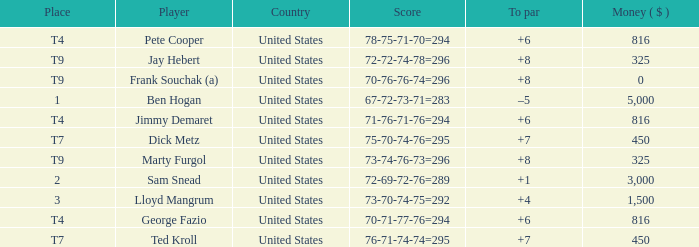Which country is Pete Cooper, who made $816, from? United States. Parse the full table. {'header': ['Place', 'Player', 'Country', 'Score', 'To par', 'Money ( $ )'], 'rows': [['T4', 'Pete Cooper', 'United States', '78-75-71-70=294', '+6', '816'], ['T9', 'Jay Hebert', 'United States', '72-72-74-78=296', '+8', '325'], ['T9', 'Frank Souchak (a)', 'United States', '70-76-76-74=296', '+8', '0'], ['1', 'Ben Hogan', 'United States', '67-72-73-71=283', '–5', '5,000'], ['T4', 'Jimmy Demaret', 'United States', '71-76-71-76=294', '+6', '816'], ['T7', 'Dick Metz', 'United States', '75-70-74-76=295', '+7', '450'], ['T9', 'Marty Furgol', 'United States', '73-74-76-73=296', '+8', '325'], ['2', 'Sam Snead', 'United States', '72-69-72-76=289', '+1', '3,000'], ['3', 'Lloyd Mangrum', 'United States', '73-70-74-75=292', '+4', '1,500'], ['T4', 'George Fazio', 'United States', '70-71-77-76=294', '+6', '816'], ['T7', 'Ted Kroll', 'United States', '76-71-74-74=295', '+7', '450']]} 